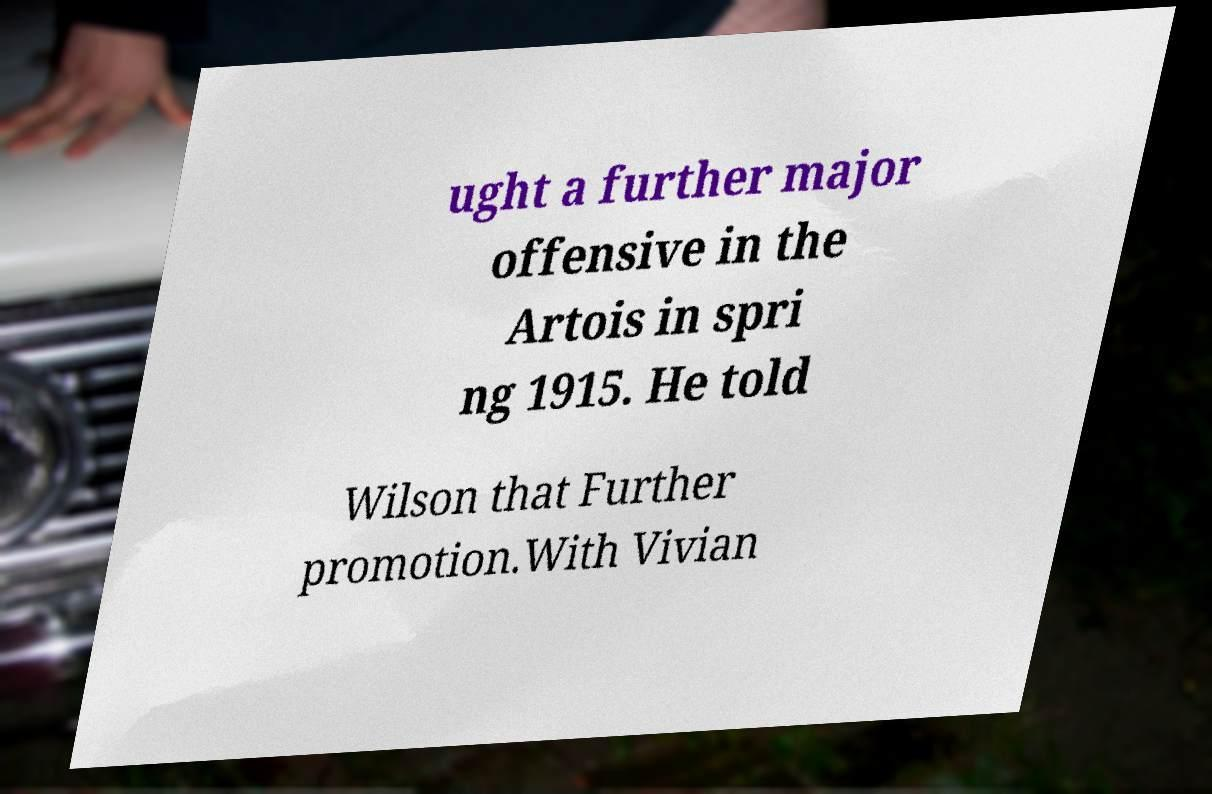Can you accurately transcribe the text from the provided image for me? ught a further major offensive in the Artois in spri ng 1915. He told Wilson that Further promotion.With Vivian 